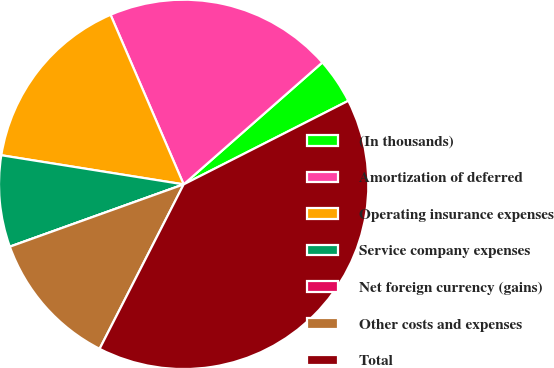Convert chart. <chart><loc_0><loc_0><loc_500><loc_500><pie_chart><fcel>(In thousands)<fcel>Amortization of deferred<fcel>Operating insurance expenses<fcel>Service company expenses<fcel>Net foreign currency (gains)<fcel>Other costs and expenses<fcel>Total<nl><fcel>4.0%<fcel>20.0%<fcel>16.0%<fcel>8.0%<fcel>0.0%<fcel>12.0%<fcel>40.0%<nl></chart> 